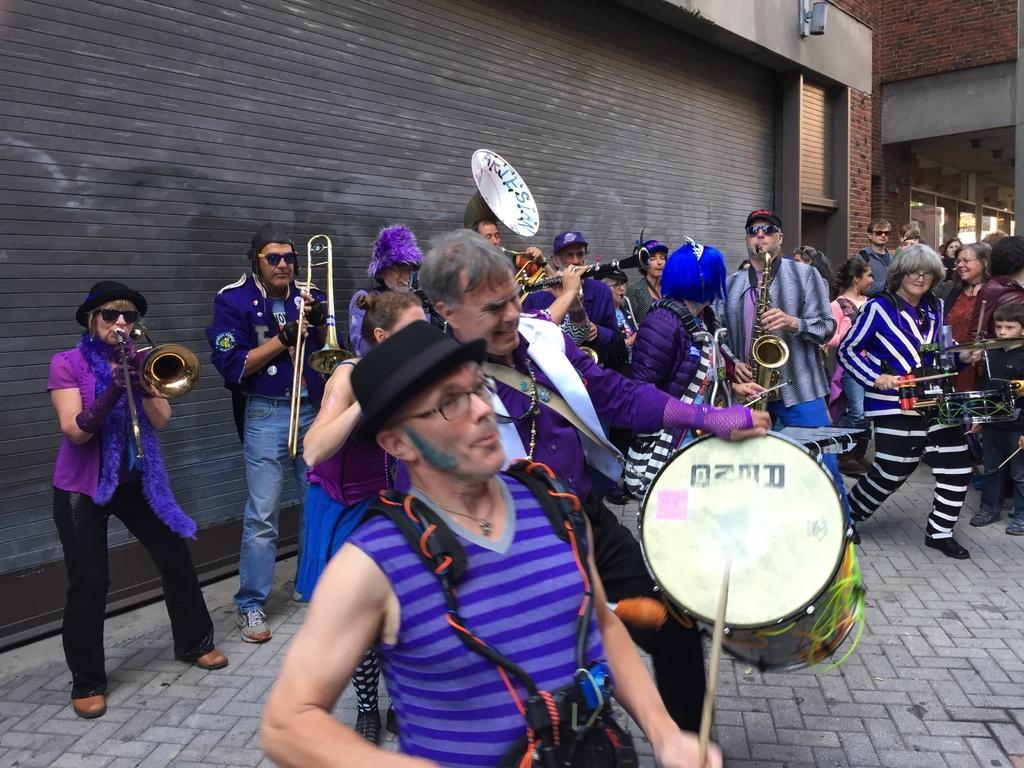In one or two sentences, can you explain what this image depicts? In this picture there are many people dancing and playing a different musical instruments in their hands. There are men and women in this group. In the background there is a wall. 